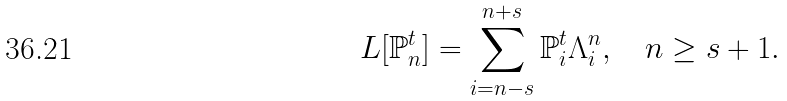Convert formula to latex. <formula><loc_0><loc_0><loc_500><loc_500>L [ \mathbb { P } _ { n } ^ { t } ] = \sum _ { i = n - s } ^ { n + s } \mathbb { P } _ { i } ^ { t } \Lambda _ { i } ^ { n } , \quad n \geq s + 1 .</formula> 